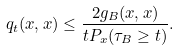<formula> <loc_0><loc_0><loc_500><loc_500>q _ { t } ( x , x ) \leq \frac { 2 g _ { B } ( x , x ) } { t P _ { x } ( \tau _ { B } \geq t ) } .</formula> 